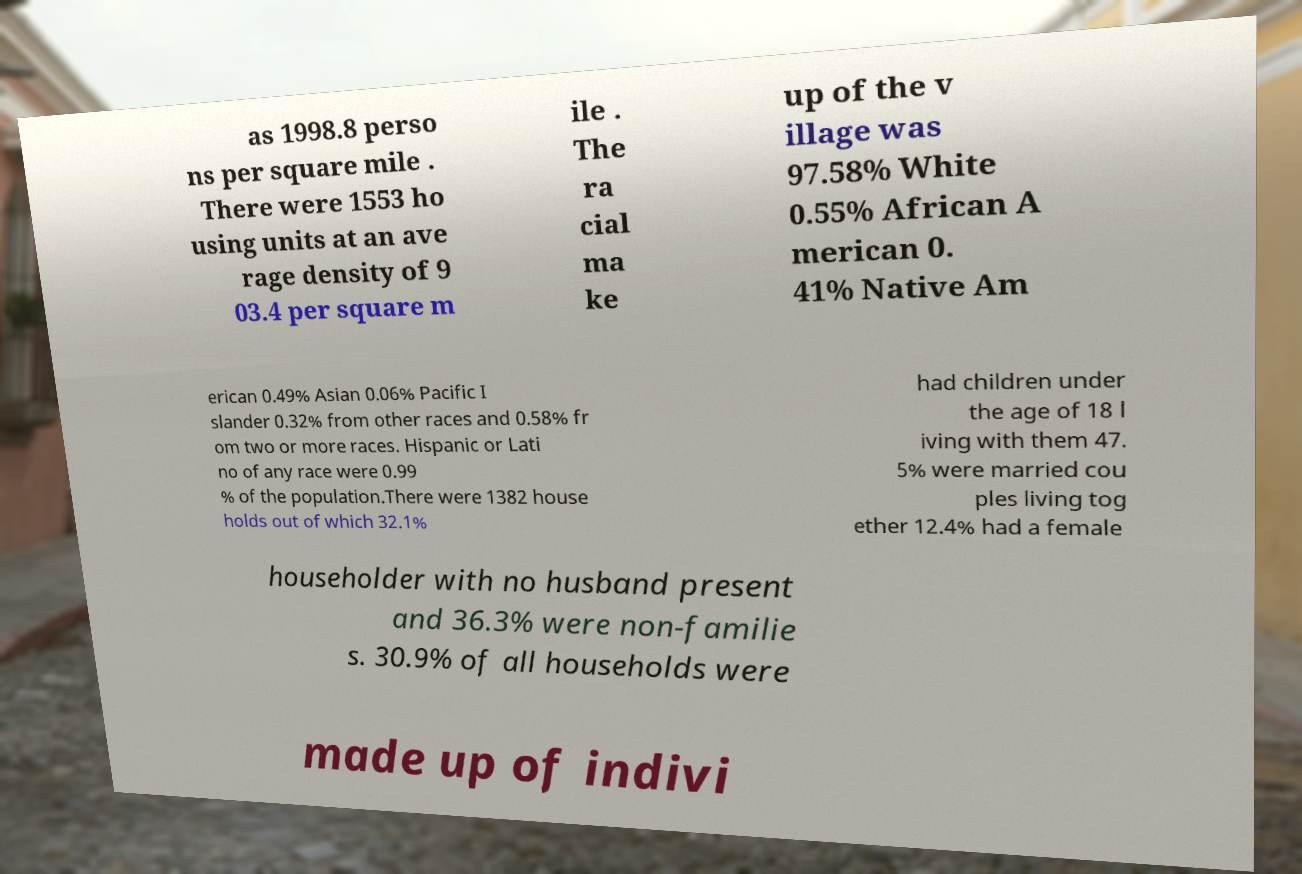Could you assist in decoding the text presented in this image and type it out clearly? as 1998.8 perso ns per square mile . There were 1553 ho using units at an ave rage density of 9 03.4 per square m ile . The ra cial ma ke up of the v illage was 97.58% White 0.55% African A merican 0. 41% Native Am erican 0.49% Asian 0.06% Pacific I slander 0.32% from other races and 0.58% fr om two or more races. Hispanic or Lati no of any race were 0.99 % of the population.There were 1382 house holds out of which 32.1% had children under the age of 18 l iving with them 47. 5% were married cou ples living tog ether 12.4% had a female householder with no husband present and 36.3% were non-familie s. 30.9% of all households were made up of indivi 